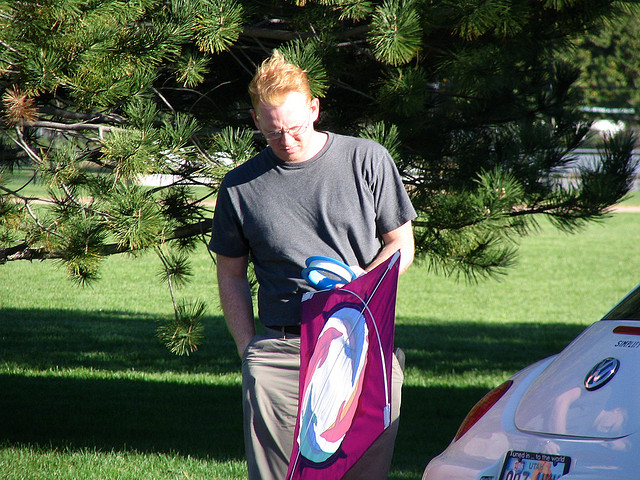Please transcribe the text information in this image. SIMPLICITY W sured is to the world 